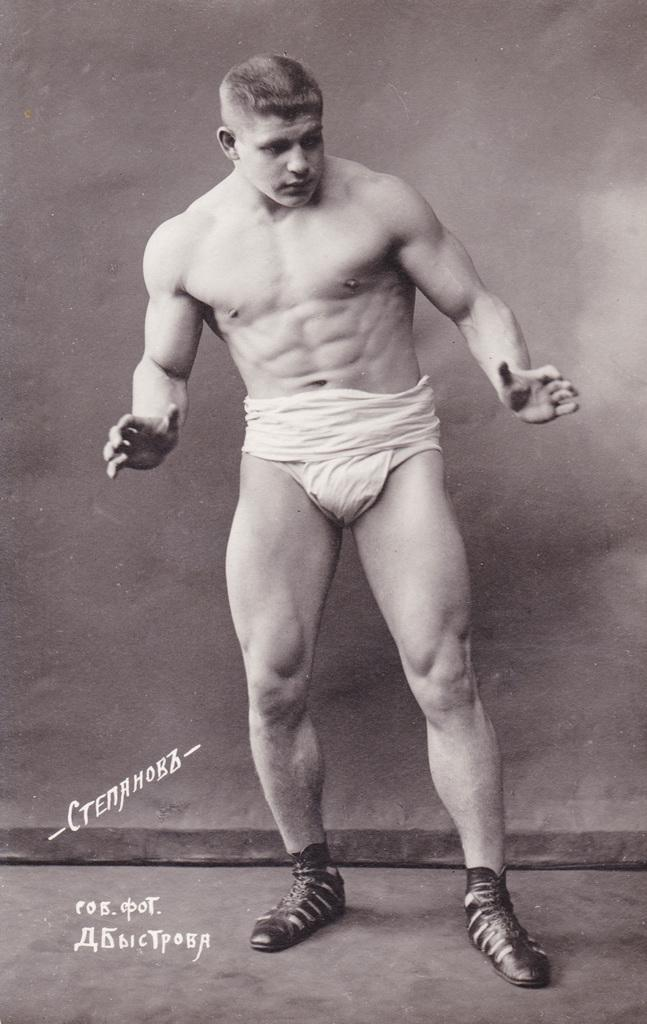What is the main subject of the image? There is a person standing in the image. What else can be seen in the image besides the person? There is a poster with text and a banner in the background of the image. How many bikes are being cut with scissors in the image? There are no bikes or scissors present in the image. 